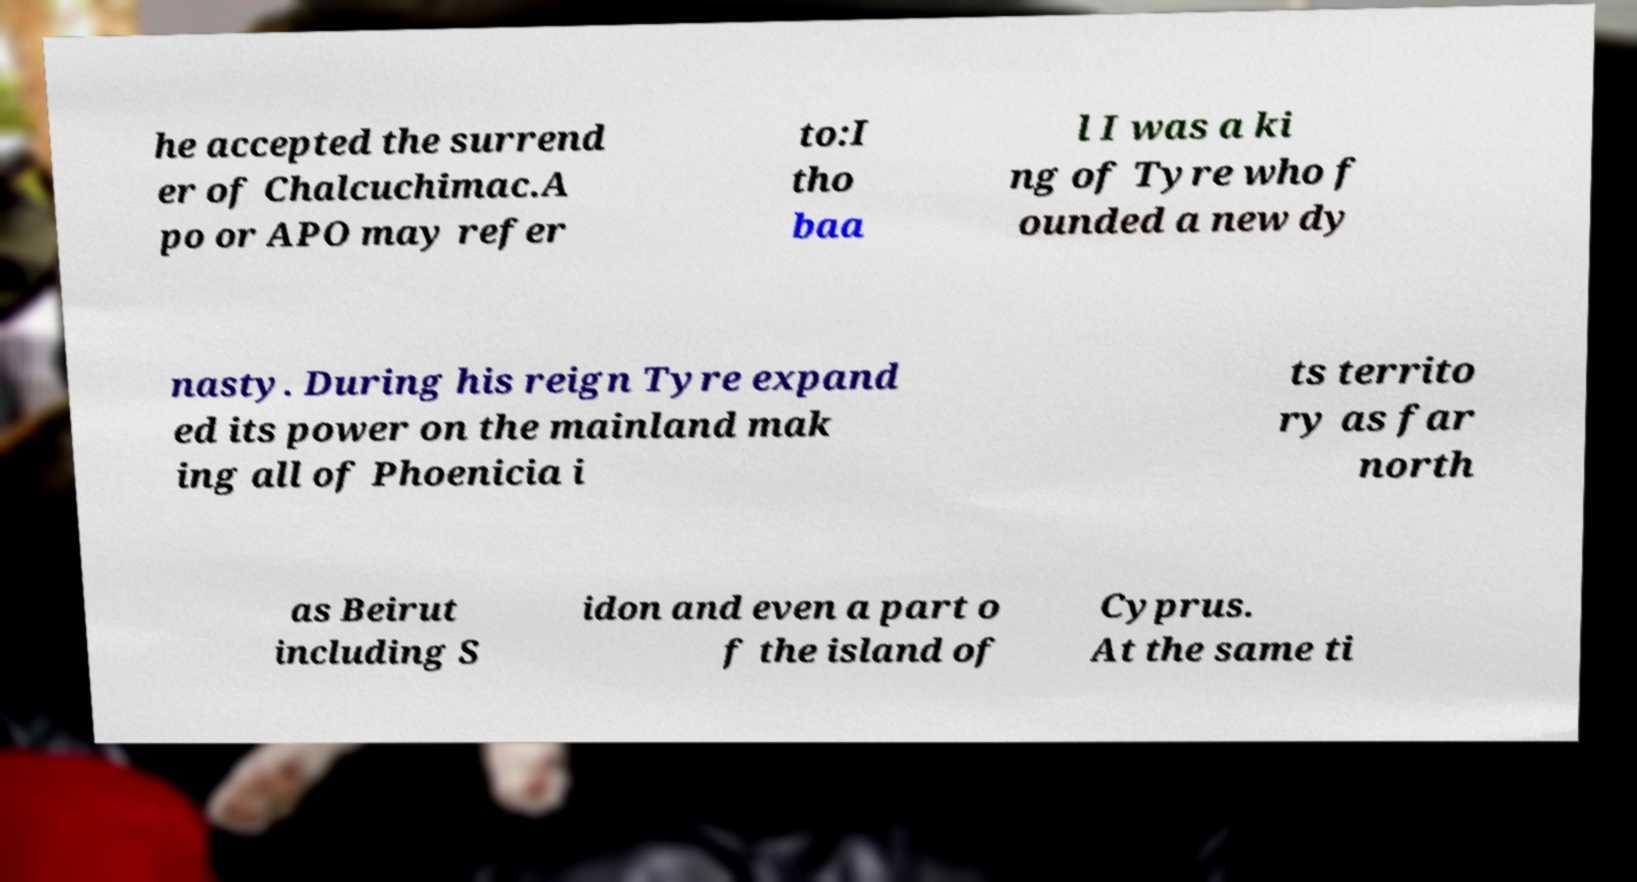Please identify and transcribe the text found in this image. he accepted the surrend er of Chalcuchimac.A po or APO may refer to:I tho baa l I was a ki ng of Tyre who f ounded a new dy nasty. During his reign Tyre expand ed its power on the mainland mak ing all of Phoenicia i ts territo ry as far north as Beirut including S idon and even a part o f the island of Cyprus. At the same ti 